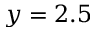Convert formula to latex. <formula><loc_0><loc_0><loc_500><loc_500>y = 2 . 5</formula> 